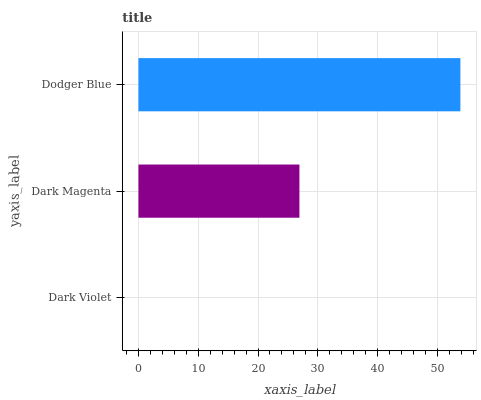Is Dark Violet the minimum?
Answer yes or no. Yes. Is Dodger Blue the maximum?
Answer yes or no. Yes. Is Dark Magenta the minimum?
Answer yes or no. No. Is Dark Magenta the maximum?
Answer yes or no. No. Is Dark Magenta greater than Dark Violet?
Answer yes or no. Yes. Is Dark Violet less than Dark Magenta?
Answer yes or no. Yes. Is Dark Violet greater than Dark Magenta?
Answer yes or no. No. Is Dark Magenta less than Dark Violet?
Answer yes or no. No. Is Dark Magenta the high median?
Answer yes or no. Yes. Is Dark Magenta the low median?
Answer yes or no. Yes. Is Dark Violet the high median?
Answer yes or no. No. Is Dodger Blue the low median?
Answer yes or no. No. 